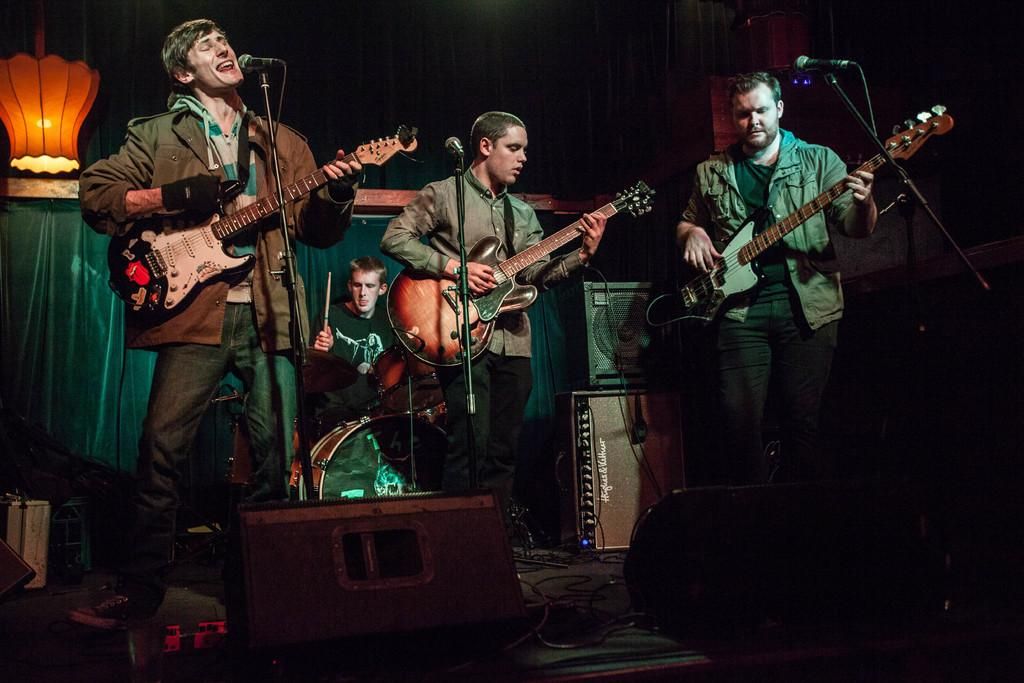How many people are on the stage in the image? There are four people on the stage in the image. What are the people on the stage doing? The people are performing by singing on a mic and playing musical instruments. What can be seen in the background of the image? There is a light and a banner in the background. What type of hand can be seen holding the microphone in the image? There is no hand holding the microphone in the image; the people are holding the microphone with their arms. 